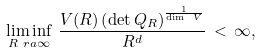Convert formula to latex. <formula><loc_0><loc_0><loc_500><loc_500>\liminf _ { R \ r a \infty } \, \frac { V ( R ) \left ( \det Q _ { R } \right ) ^ { \frac { 1 } { \dim \ V } } } { R ^ { d } } \, < \, \infty ,</formula> 